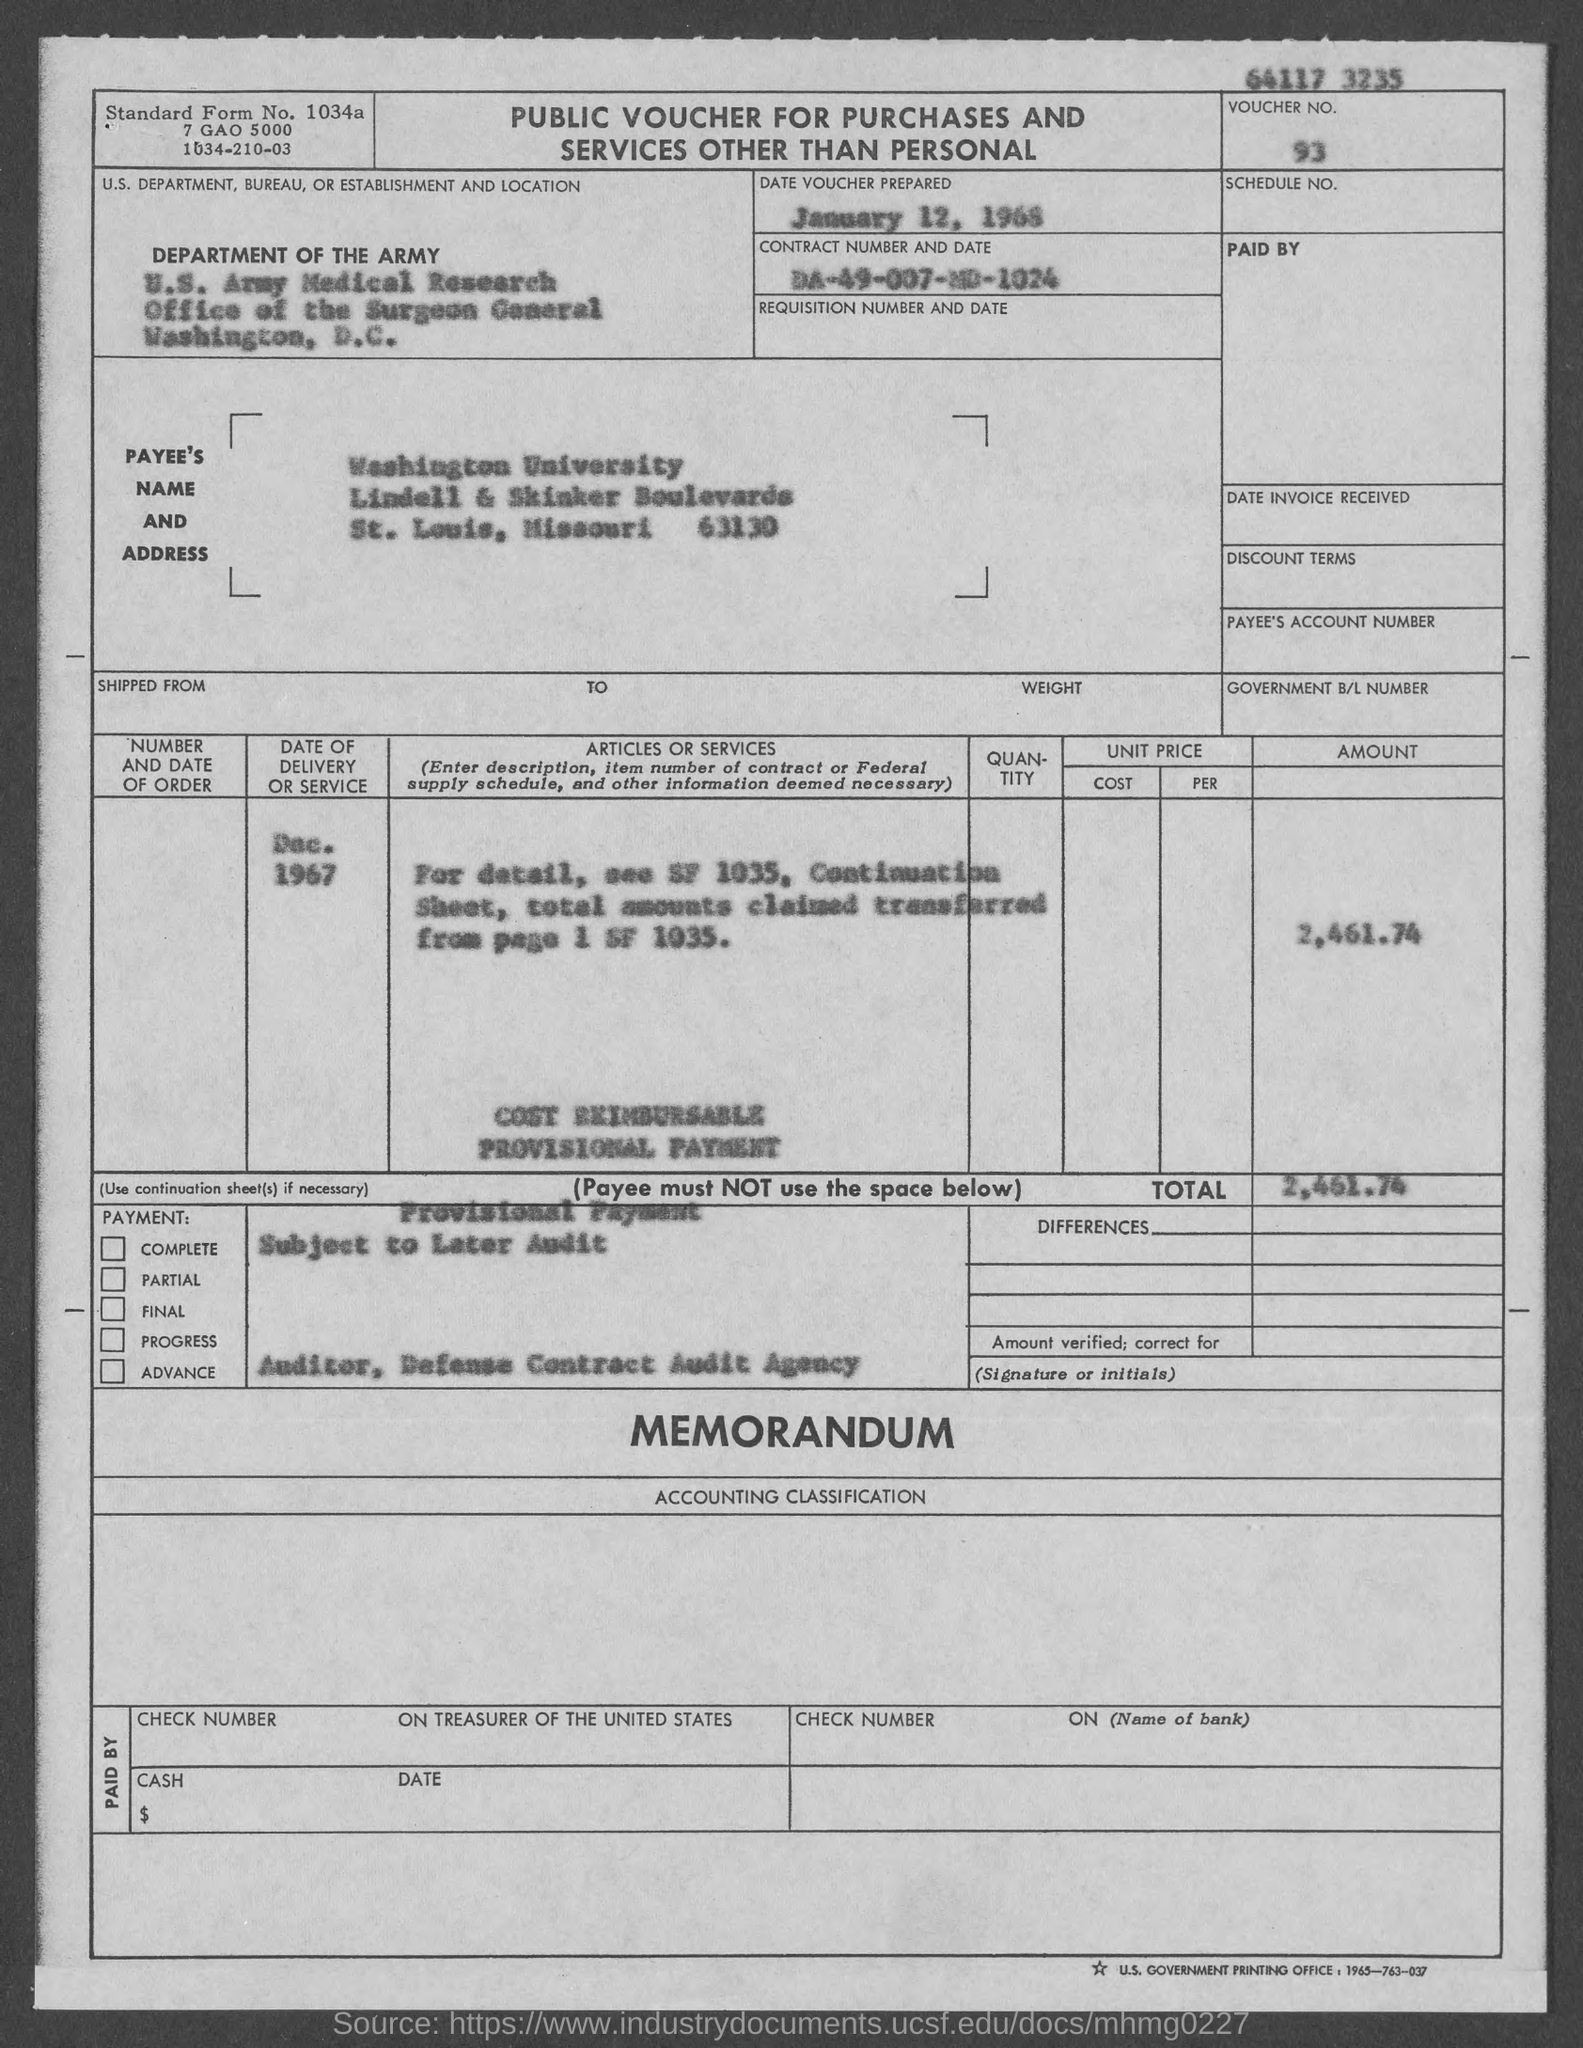Identify some key points in this picture. The voucher number is 93... The main heading of the document is "Public Voucher for Purchases and Services Other than Personal". The date of delivery or service was December 1967. The total cost is 2,461.74. 